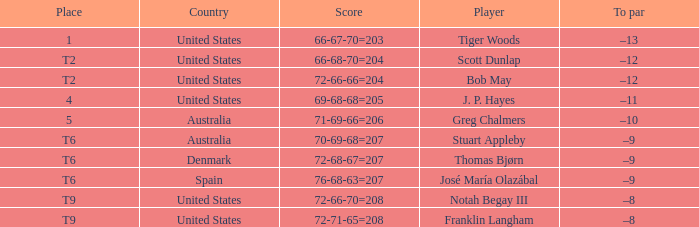What is the place of the player with a 72-71-65=208 score? T9. 